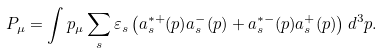Convert formula to latex. <formula><loc_0><loc_0><loc_500><loc_500>P _ { \mu } = \int p _ { \mu } \sum _ { s } \varepsilon _ { s } \left ( a _ { s } ^ { * + } ( p ) a _ { s } ^ { - } ( p ) + a _ { s } ^ { * - } ( p ) a _ { s } ^ { + } ( p ) \right ) d ^ { 3 } p .</formula> 